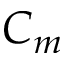Convert formula to latex. <formula><loc_0><loc_0><loc_500><loc_500>C _ { m }</formula> 